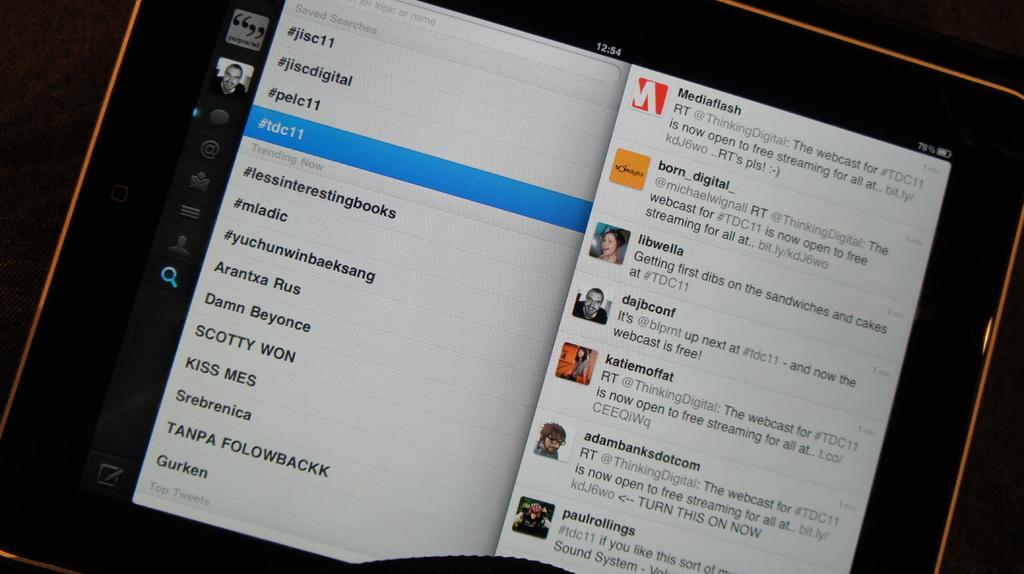How would you summarize this image in a sentence or two? In this image, we can see an electronic gadget. On the screen, we can see some pictures and text written on it. 